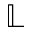Convert formula to latex. <formula><loc_0><loc_0><loc_500><loc_500>\mathbb { L }</formula> 